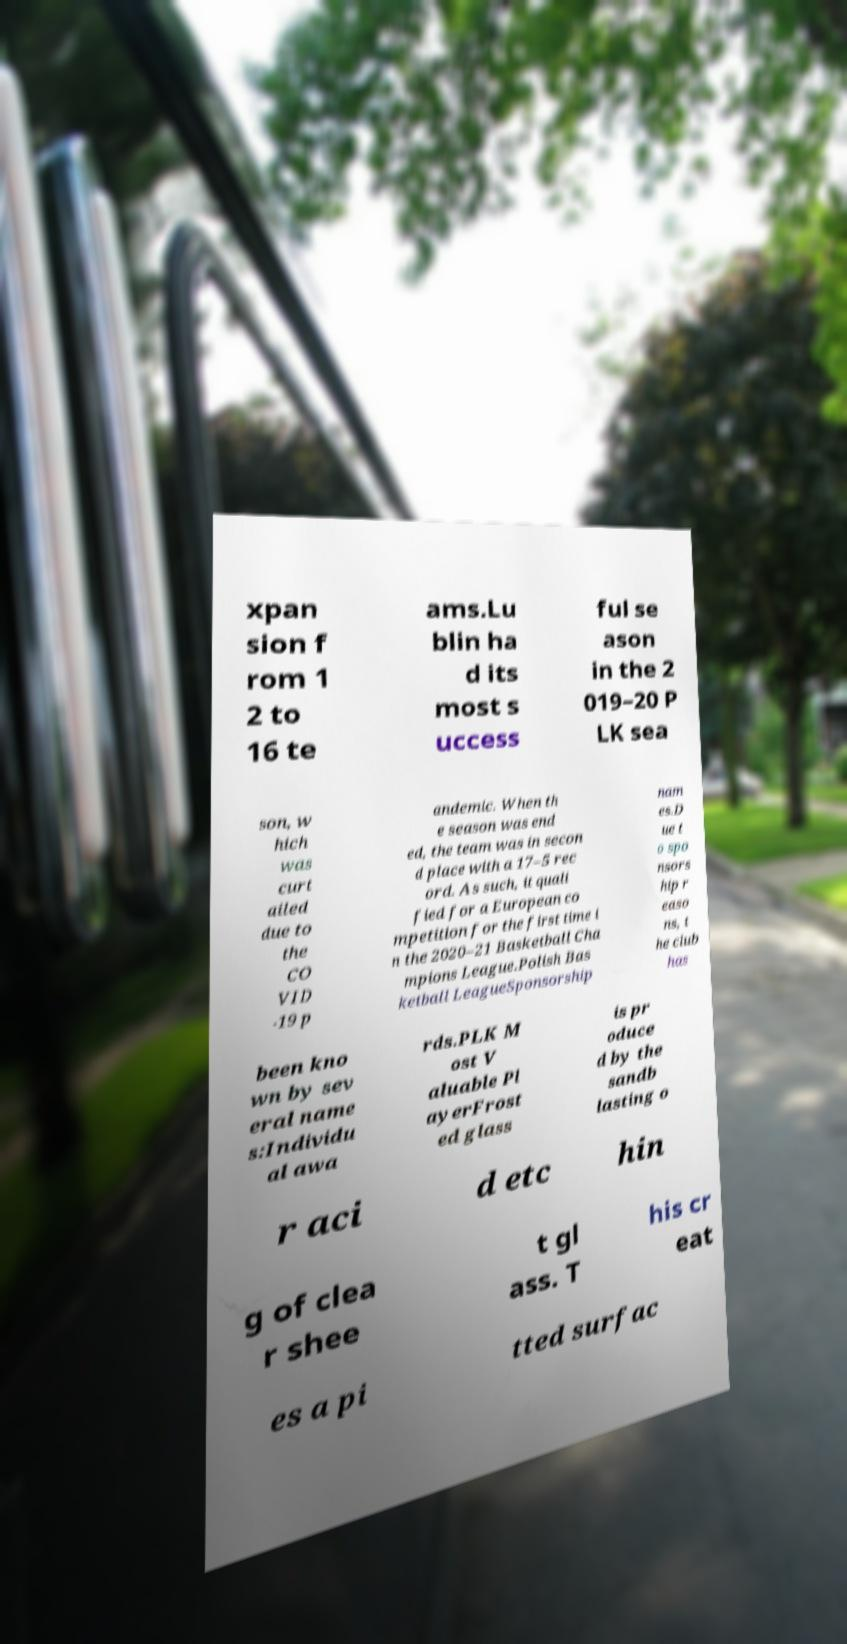There's text embedded in this image that I need extracted. Can you transcribe it verbatim? xpan sion f rom 1 2 to 16 te ams.Lu blin ha d its most s uccess ful se ason in the 2 019–20 P LK sea son, w hich was curt ailed due to the CO VID -19 p andemic. When th e season was end ed, the team was in secon d place with a 17–5 rec ord. As such, it quali fied for a European co mpetition for the first time i n the 2020–21 Basketball Cha mpions League.Polish Bas ketball LeagueSponsorship nam es.D ue t o spo nsors hip r easo ns, t he club has been kno wn by sev eral name s:Individu al awa rds.PLK M ost V aluable Pl ayerFrost ed glass is pr oduce d by the sandb lasting o r aci d etc hin g of clea r shee t gl ass. T his cr eat es a pi tted surfac 